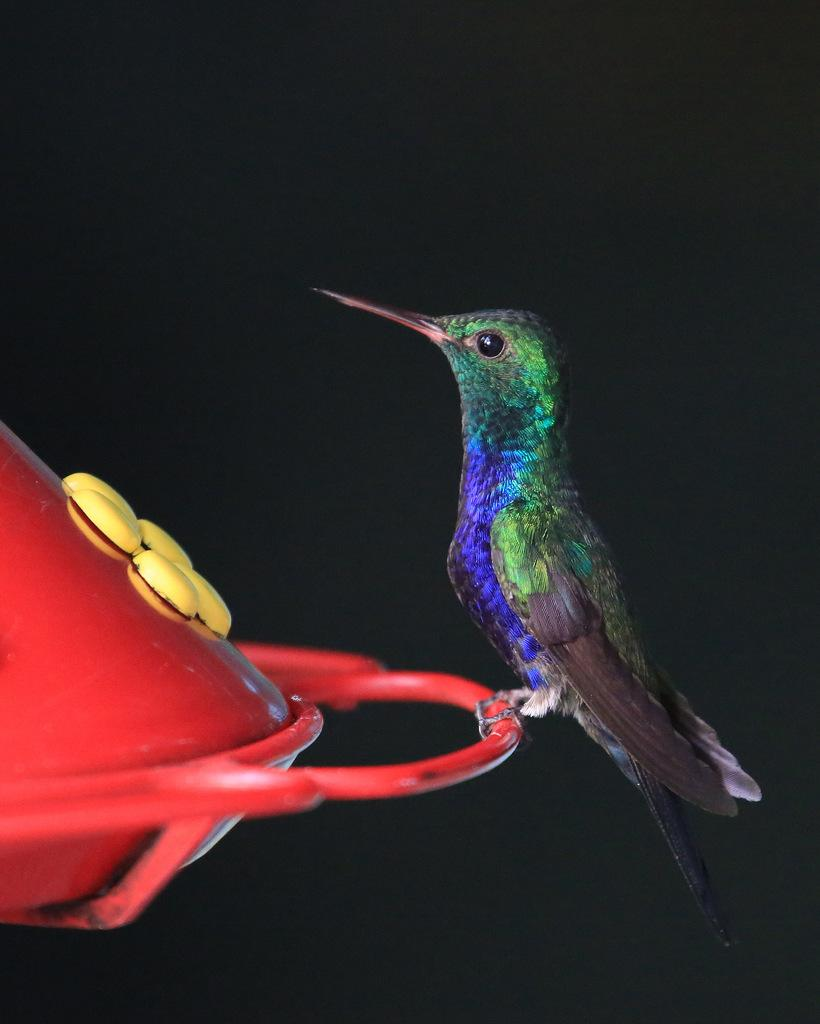What type of animal is present in the image? There is a bird in the image. What is the bird doing in the image? The bird is sitting on an object. What color is the background of the image? The background of the image is black in color. What type of weather can be seen in the image? There is no indication of weather in the image, as it features a bird sitting on an object with a black background. What type of coat is the bird wearing in the image? Birds do not wear coats, so this question cannot be answered definitively from the image. 